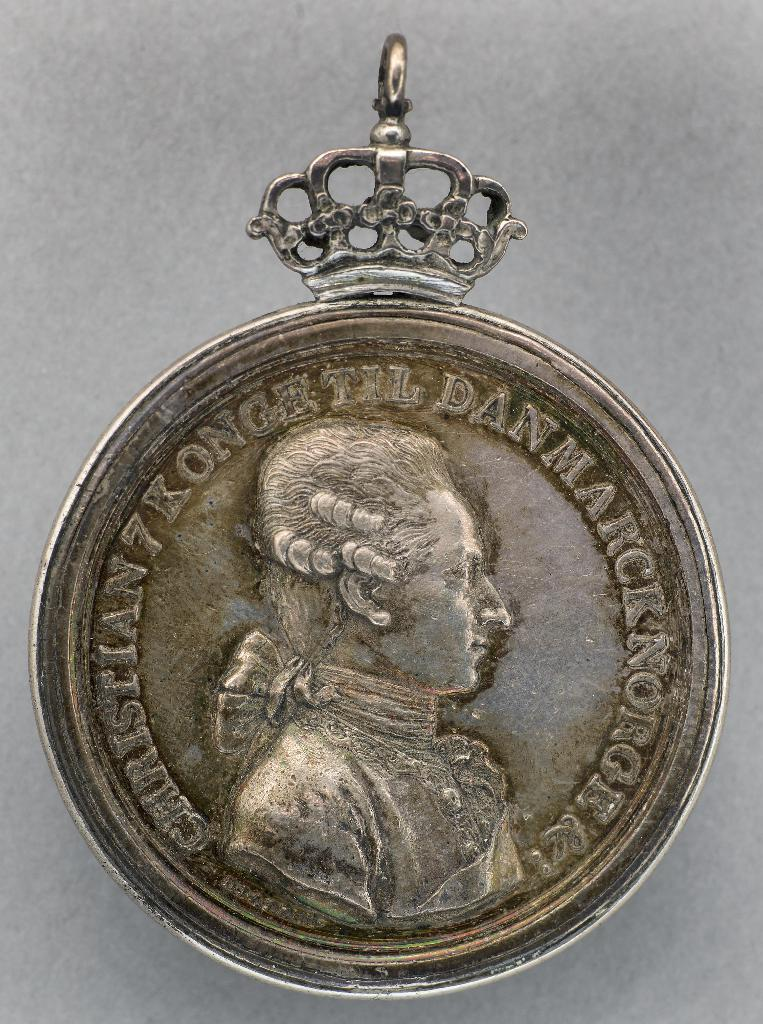What is the main object in the image? There is a locket in the image. What is depicted on the locket? The locket has an engraving of a sculpture. Where is the camera placed in the image? There is no camera present in the image; it only features a locket with an engraving of a sculpture. 